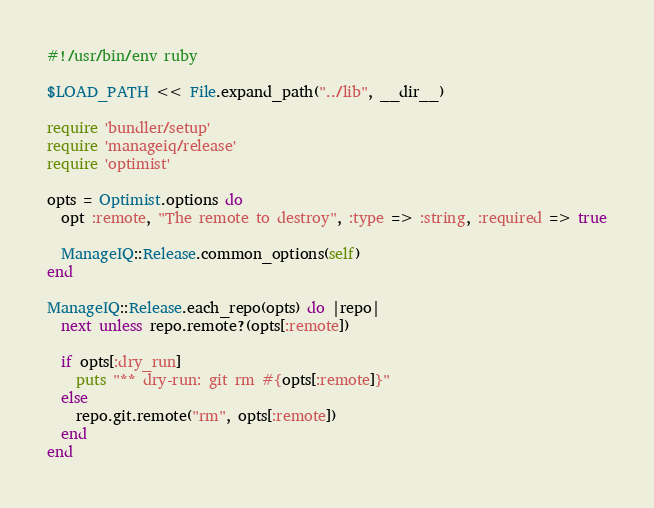Convert code to text. <code><loc_0><loc_0><loc_500><loc_500><_Ruby_>#!/usr/bin/env ruby

$LOAD_PATH << File.expand_path("../lib", __dir__)

require 'bundler/setup'
require 'manageiq/release'
require 'optimist'

opts = Optimist.options do
  opt :remote, "The remote to destroy", :type => :string, :required => true

  ManageIQ::Release.common_options(self)
end

ManageIQ::Release.each_repo(opts) do |repo|
  next unless repo.remote?(opts[:remote])

  if opts[:dry_run]
    puts "** dry-run: git rm #{opts[:remote]}"
  else
    repo.git.remote("rm", opts[:remote])
  end
end
</code> 